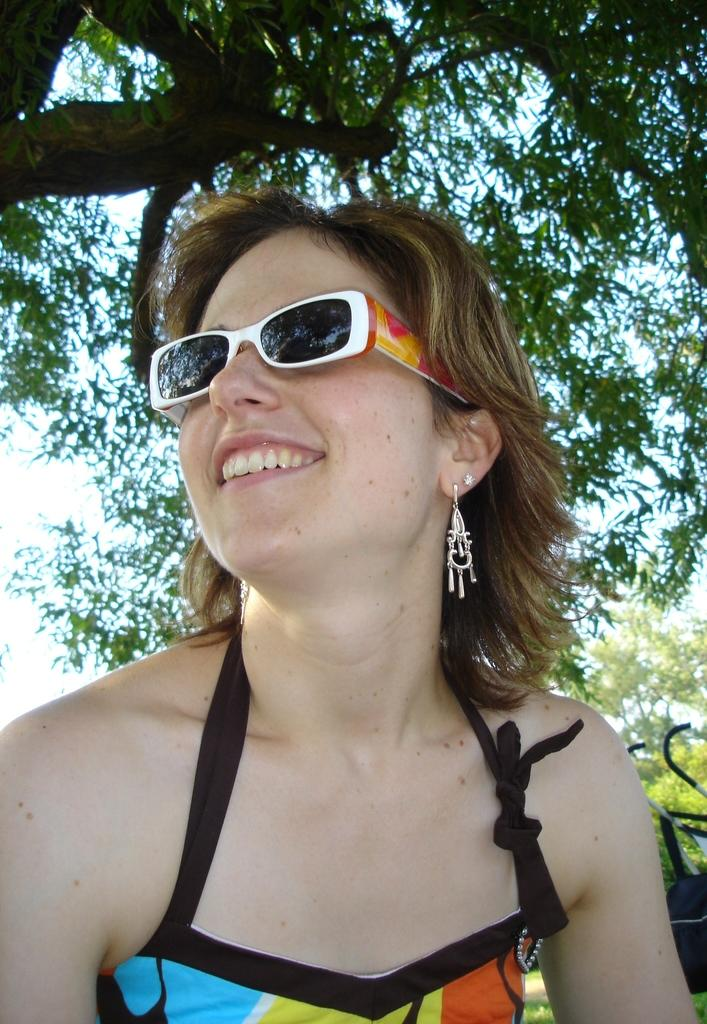Who is present in the image? There is a woman in the image. What is the woman wearing on her face? The woman is wearing shades. What can be seen in the background of the image? There is a tree in the background of the image. What type of wrench is the woman using in the image? There is no wrench present in the image; the woman is wearing shades and standing in front of a tree. 